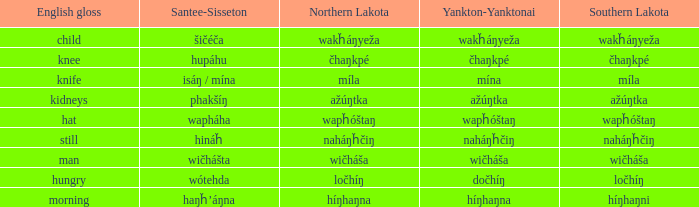Name the number of english gloss for wakȟáŋyeža 1.0. 